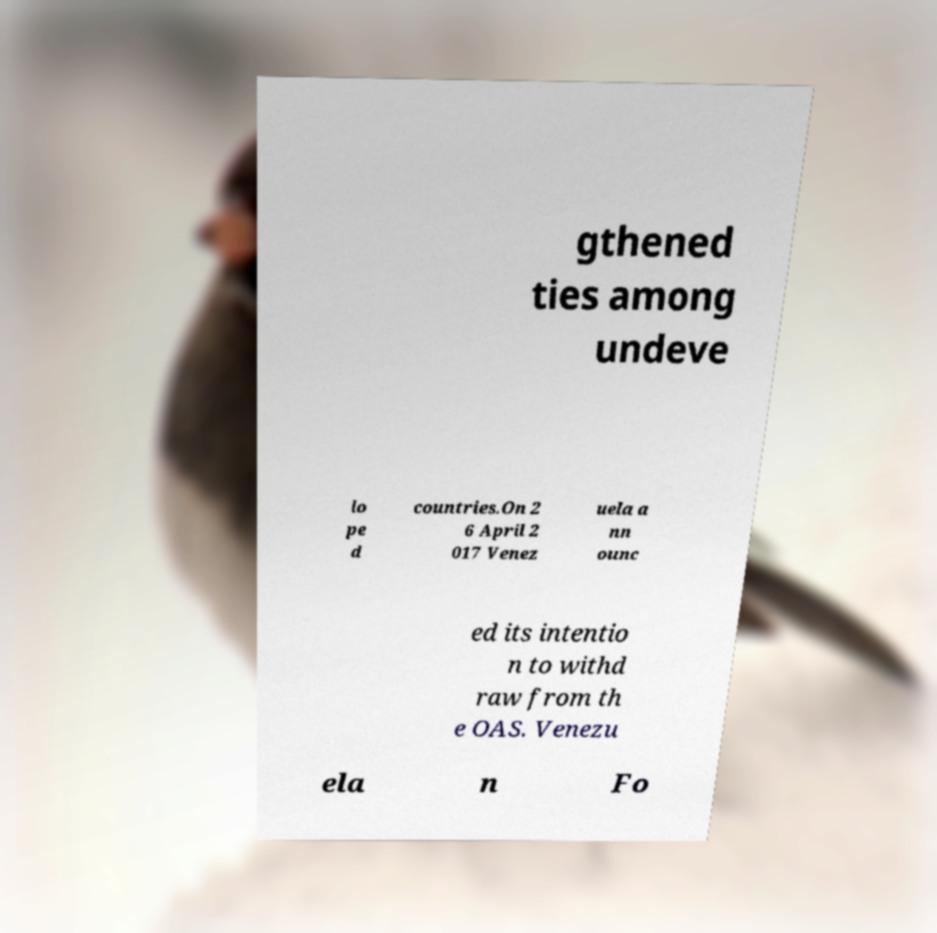Could you extract and type out the text from this image? gthened ties among undeve lo pe d countries.On 2 6 April 2 017 Venez uela a nn ounc ed its intentio n to withd raw from th e OAS. Venezu ela n Fo 